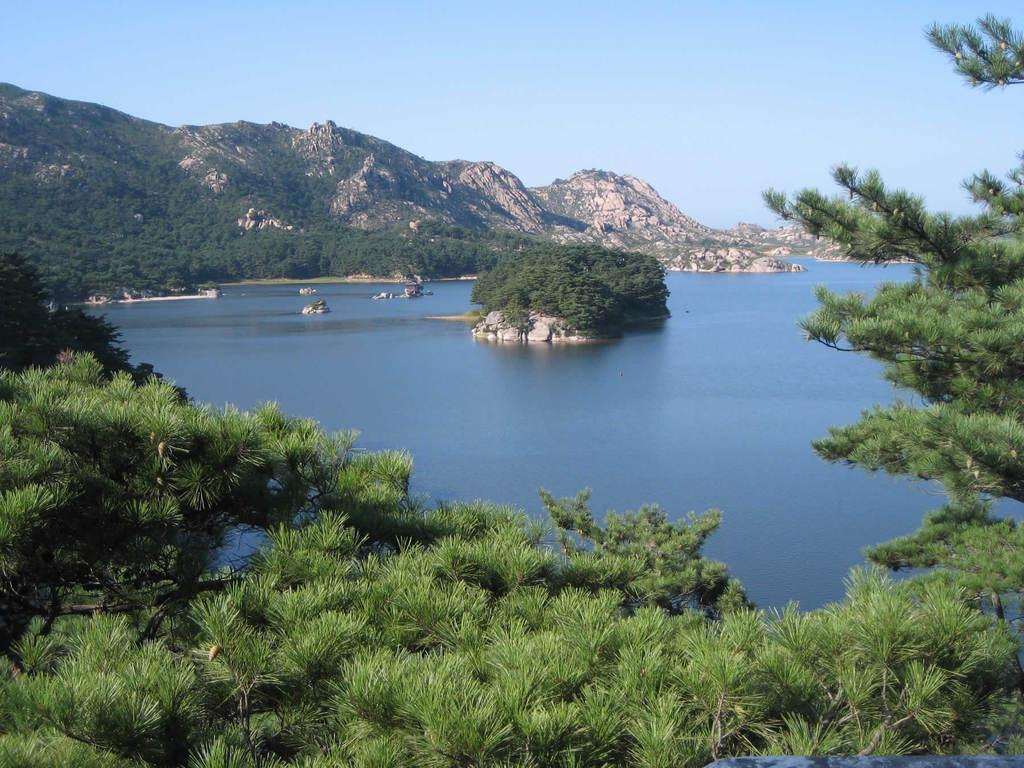What is the main feature in the center of the image? There is a lake in the center of the image. What type of vegetation is present at the bottom of the image? There are trees at the bottom of the image. What can be seen in the distance in the image? There are hills in the background of the image. What is visible in the sky in the image? The sky is visible in the background of the image. What type of hobbies does the judge engage in while standing near the steel structure in the image? There is no judge or steel structure present in the image. 